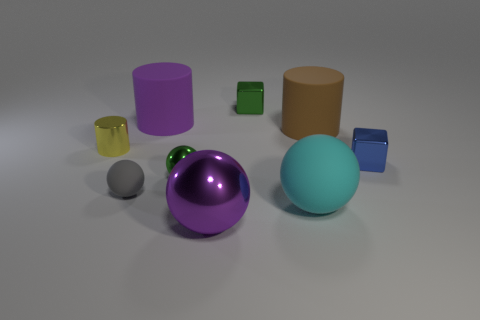Subtract all green metal spheres. How many spheres are left? 3 Subtract all green blocks. How many blocks are left? 1 Subtract 0 blue cylinders. How many objects are left? 9 Subtract all cylinders. How many objects are left? 6 Subtract 3 spheres. How many spheres are left? 1 Subtract all cyan blocks. Subtract all gray cylinders. How many blocks are left? 2 Subtract all green cubes. How many yellow spheres are left? 0 Subtract all yellow metal cylinders. Subtract all large purple cylinders. How many objects are left? 7 Add 9 yellow things. How many yellow things are left? 10 Add 8 small gray shiny things. How many small gray shiny things exist? 8 